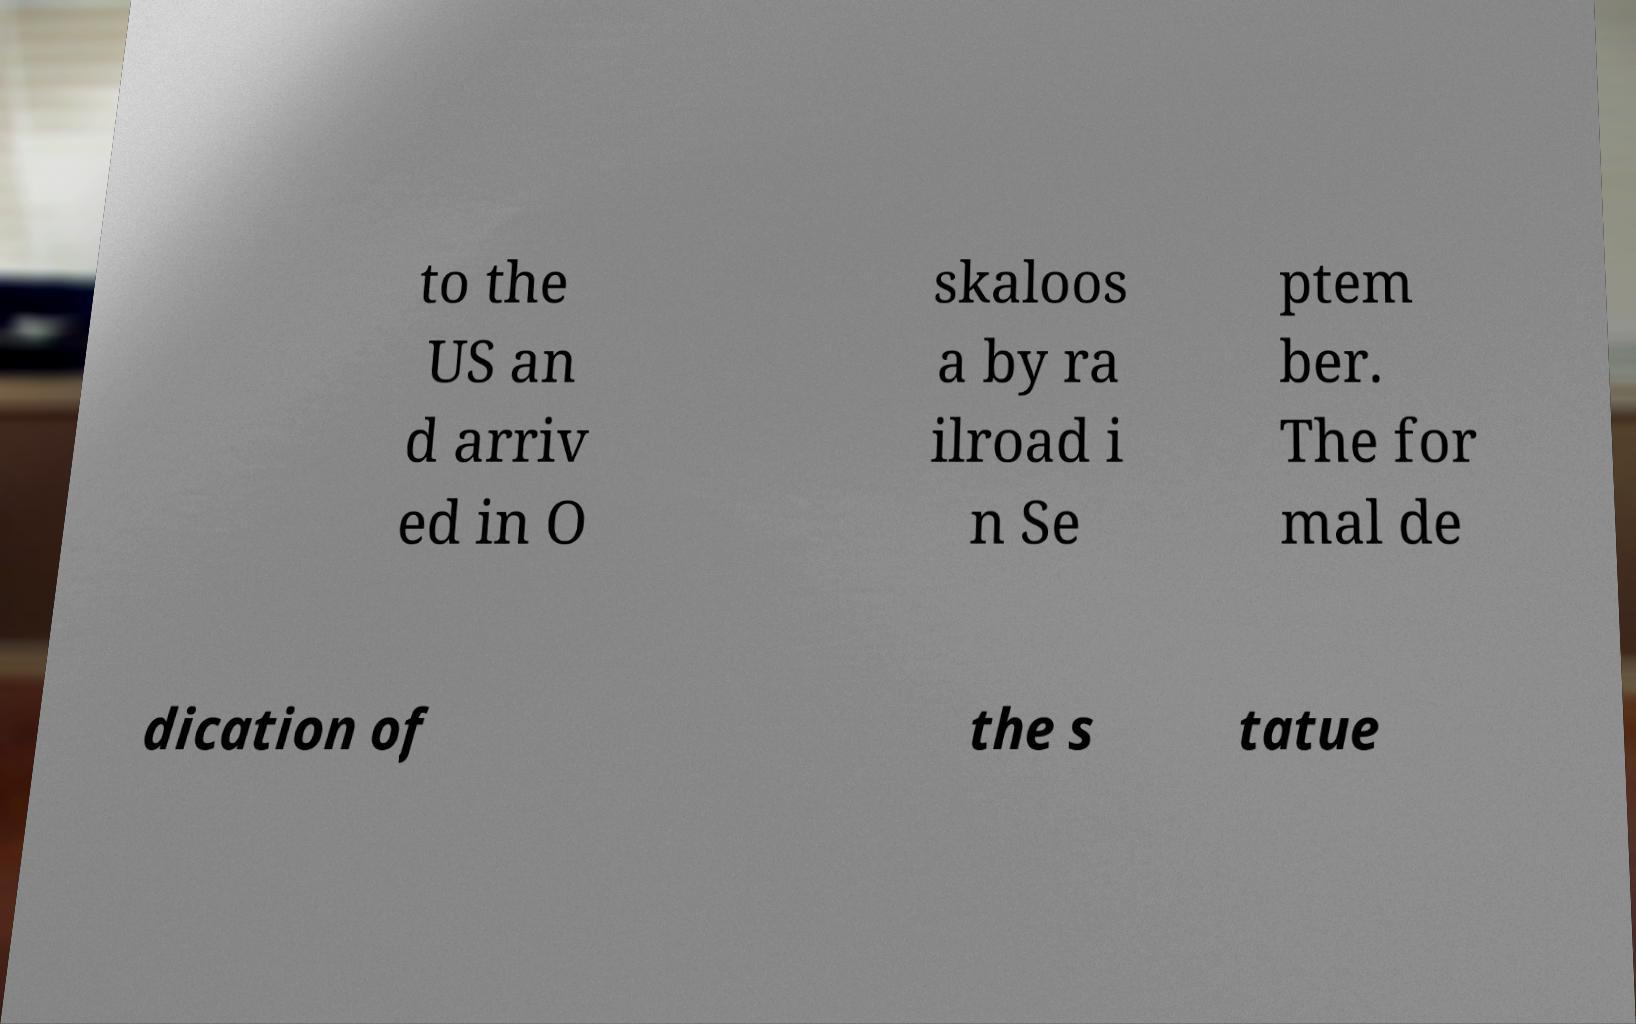What messages or text are displayed in this image? I need them in a readable, typed format. to the US an d arriv ed in O skaloos a by ra ilroad i n Se ptem ber. The for mal de dication of the s tatue 